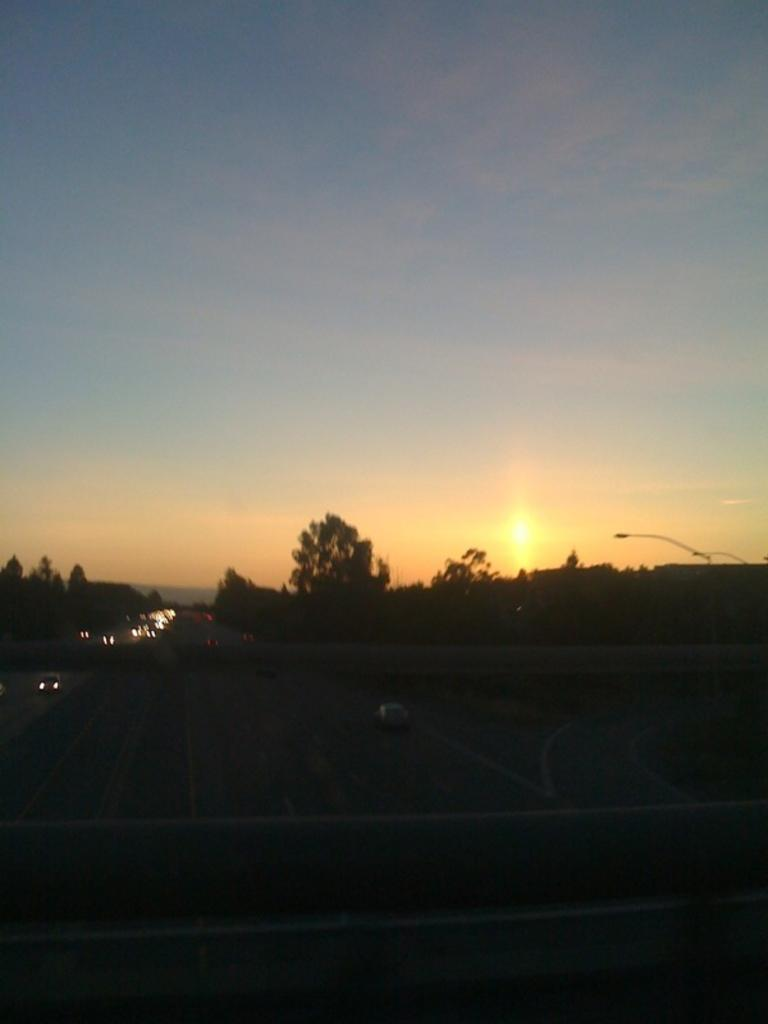What types of vehicles can be seen in the image? There are vehicles in the image, but the specific types are not mentioned. What structure is present in the image that allows vehicles to cross over a body of water or gap? There is a bridge in the image. What surface can be seen in the image that vehicles typically travel on? There is a road in the image. What type of vegetation is visible in the image? There are trees in the image. What type of lighting is present in the image to illuminate the road at night? There are street lights in the image. What celestial body is visible in the background of the image? The sun is visible in the background of the image. What part of the natural environment is visible in the background of the image? The sky is visible in the background of the image, and there are clouds present. Where can the chalk be found in the image? There is no chalk present in the image. What type of list is being used by the vehicles in the image? There is no list present in the image, and vehicles do not use lists. Is there a stream visible in the image? There is no mention of a stream in the provided facts, so it cannot be determined if one is present in the image. 